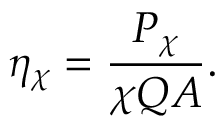<formula> <loc_0><loc_0><loc_500><loc_500>\eta _ { \chi } = { \frac { P _ { \chi } } { \chi Q A } } .</formula> 